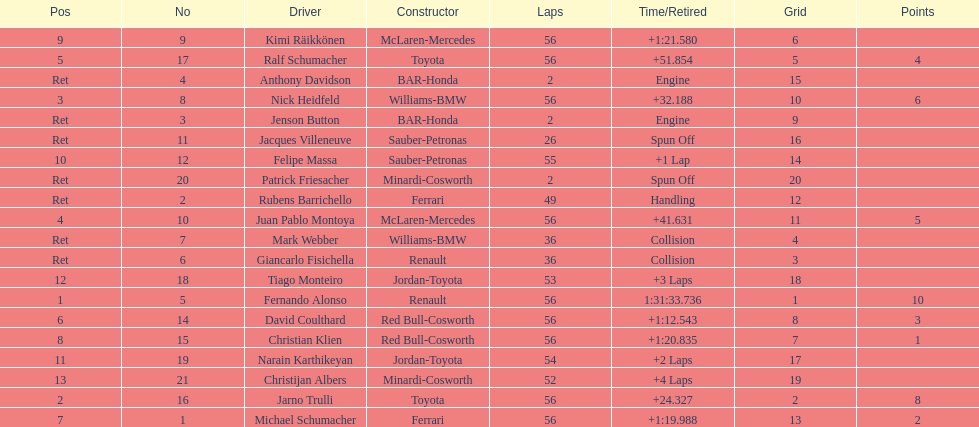How long did it take fernando alonso to finish the race? 1:31:33.736. I'm looking to parse the entire table for insights. Could you assist me with that? {'header': ['Pos', 'No', 'Driver', 'Constructor', 'Laps', 'Time/Retired', 'Grid', 'Points'], 'rows': [['9', '9', 'Kimi Räikkönen', 'McLaren-Mercedes', '56', '+1:21.580', '6', ''], ['5', '17', 'Ralf Schumacher', 'Toyota', '56', '+51.854', '5', '4'], ['Ret', '4', 'Anthony Davidson', 'BAR-Honda', '2', 'Engine', '15', ''], ['3', '8', 'Nick Heidfeld', 'Williams-BMW', '56', '+32.188', '10', '6'], ['Ret', '3', 'Jenson Button', 'BAR-Honda', '2', 'Engine', '9', ''], ['Ret', '11', 'Jacques Villeneuve', 'Sauber-Petronas', '26', 'Spun Off', '16', ''], ['10', '12', 'Felipe Massa', 'Sauber-Petronas', '55', '+1 Lap', '14', ''], ['Ret', '20', 'Patrick Friesacher', 'Minardi-Cosworth', '2', 'Spun Off', '20', ''], ['Ret', '2', 'Rubens Barrichello', 'Ferrari', '49', 'Handling', '12', ''], ['4', '10', 'Juan Pablo Montoya', 'McLaren-Mercedes', '56', '+41.631', '11', '5'], ['Ret', '7', 'Mark Webber', 'Williams-BMW', '36', 'Collision', '4', ''], ['Ret', '6', 'Giancarlo Fisichella', 'Renault', '36', 'Collision', '3', ''], ['12', '18', 'Tiago Monteiro', 'Jordan-Toyota', '53', '+3 Laps', '18', ''], ['1', '5', 'Fernando Alonso', 'Renault', '56', '1:31:33.736', '1', '10'], ['6', '14', 'David Coulthard', 'Red Bull-Cosworth', '56', '+1:12.543', '8', '3'], ['8', '15', 'Christian Klien', 'Red Bull-Cosworth', '56', '+1:20.835', '7', '1'], ['11', '19', 'Narain Karthikeyan', 'Jordan-Toyota', '54', '+2 Laps', '17', ''], ['13', '21', 'Christijan Albers', 'Minardi-Cosworth', '52', '+4 Laps', '19', ''], ['2', '16', 'Jarno Trulli', 'Toyota', '56', '+24.327', '2', '8'], ['7', '1', 'Michael Schumacher', 'Ferrari', '56', '+1:19.988', '13', '2']]} 